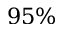<formula> <loc_0><loc_0><loc_500><loc_500>9 5 \%</formula> 